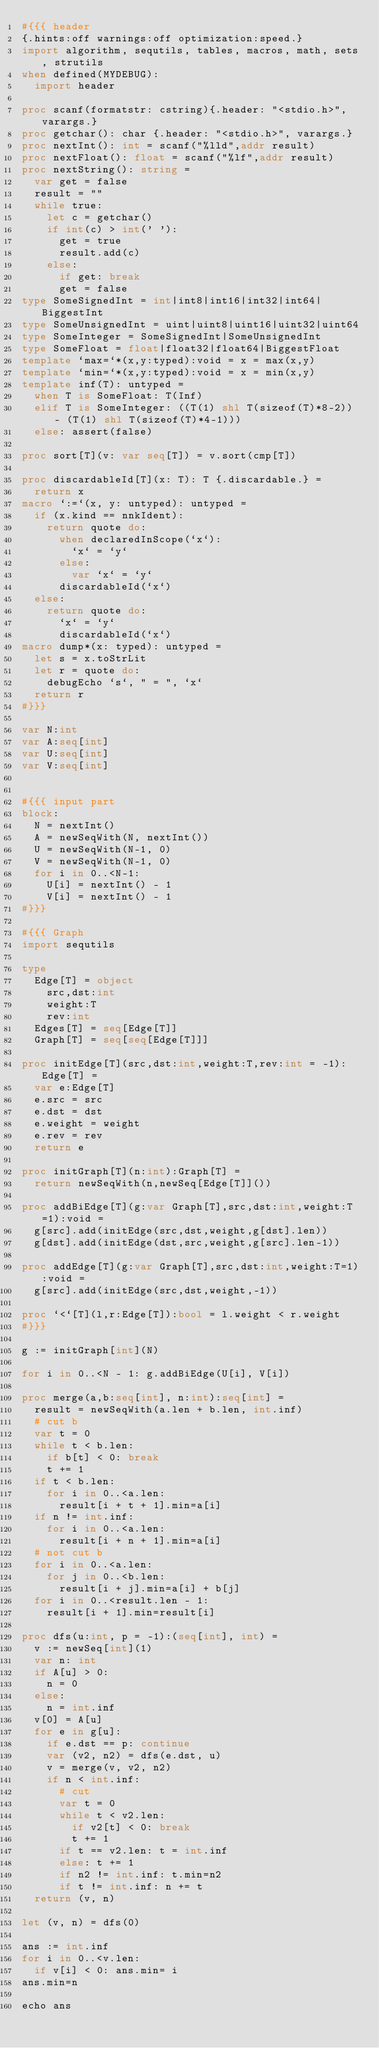Convert code to text. <code><loc_0><loc_0><loc_500><loc_500><_Nim_>#{{{ header
{.hints:off warnings:off optimization:speed.}
import algorithm, sequtils, tables, macros, math, sets, strutils
when defined(MYDEBUG):
  import header

proc scanf(formatstr: cstring){.header: "<stdio.h>", varargs.}
proc getchar(): char {.header: "<stdio.h>", varargs.}
proc nextInt(): int = scanf("%lld",addr result)
proc nextFloat(): float = scanf("%lf",addr result)
proc nextString(): string =
  var get = false
  result = ""
  while true:
    let c = getchar()
    if int(c) > int(' '):
      get = true
      result.add(c)
    else:
      if get: break
      get = false
type SomeSignedInt = int|int8|int16|int32|int64|BiggestInt
type SomeUnsignedInt = uint|uint8|uint16|uint32|uint64
type SomeInteger = SomeSignedInt|SomeUnsignedInt
type SomeFloat = float|float32|float64|BiggestFloat
template `max=`*(x,y:typed):void = x = max(x,y)
template `min=`*(x,y:typed):void = x = min(x,y)
template inf(T): untyped = 
  when T is SomeFloat: T(Inf)
  elif T is SomeInteger: ((T(1) shl T(sizeof(T)*8-2)) - (T(1) shl T(sizeof(T)*4-1)))
  else: assert(false)

proc sort[T](v: var seq[T]) = v.sort(cmp[T])

proc discardableId[T](x: T): T {.discardable.} =
  return x
macro `:=`(x, y: untyped): untyped =
  if (x.kind == nnkIdent):
    return quote do:
      when declaredInScope(`x`):
        `x` = `y`
      else:
        var `x` = `y`
      discardableId(`x`)
  else:
    return quote do:
      `x` = `y`
      discardableId(`x`)
macro dump*(x: typed): untyped =
  let s = x.toStrLit
  let r = quote do:
    debugEcho `s`, " = ", `x`
  return r
#}}}

var N:int
var A:seq[int]
var U:seq[int]
var V:seq[int]


#{{{ input part
block:
  N = nextInt()
  A = newSeqWith(N, nextInt())
  U = newSeqWith(N-1, 0)
  V = newSeqWith(N-1, 0)
  for i in 0..<N-1:
    U[i] = nextInt() - 1
    V[i] = nextInt() - 1
#}}}

#{{{ Graph
import sequtils

type
  Edge[T] = object
    src,dst:int
    weight:T
    rev:int
  Edges[T] = seq[Edge[T]]
  Graph[T] = seq[seq[Edge[T]]]

proc initEdge[T](src,dst:int,weight:T,rev:int = -1):Edge[T] =
  var e:Edge[T]
  e.src = src
  e.dst = dst
  e.weight = weight
  e.rev = rev
  return e

proc initGraph[T](n:int):Graph[T] =
  return newSeqWith(n,newSeq[Edge[T]]())

proc addBiEdge[T](g:var Graph[T],src,dst:int,weight:T=1):void =
  g[src].add(initEdge(src,dst,weight,g[dst].len))
  g[dst].add(initEdge(dst,src,weight,g[src].len-1))

proc addEdge[T](g:var Graph[T],src,dst:int,weight:T=1):void =
  g[src].add(initEdge(src,dst,weight,-1))

proc `<`[T](l,r:Edge[T]):bool = l.weight < r.weight
#}}}

g := initGraph[int](N)

for i in 0..<N - 1: g.addBiEdge(U[i], V[i])

proc merge(a,b:seq[int], n:int):seq[int] =
  result = newSeqWith(a.len + b.len, int.inf)
  # cut b
  var t = 0
  while t < b.len:
    if b[t] < 0: break
    t += 1
  if t < b.len:
    for i in 0..<a.len:
      result[i + t + 1].min=a[i]
  if n != int.inf:
    for i in 0..<a.len:
      result[i + n + 1].min=a[i]
  # not cut b
  for i in 0..<a.len:
    for j in 0..<b.len:
      result[i + j].min=a[i] + b[j]
  for i in 0..<result.len - 1:
    result[i + 1].min=result[i]

proc dfs(u:int, p = -1):(seq[int], int) =
  v := newSeq[int](1)
  var n: int
  if A[u] > 0:
    n = 0
  else:
    n = int.inf
  v[0] = A[u]
  for e in g[u]:
    if e.dst == p: continue
    var (v2, n2) = dfs(e.dst, u)
    v = merge(v, v2, n2)
    if n < int.inf:
      # cut
      var t = 0
      while t < v2.len:
        if v2[t] < 0: break
        t += 1
      if t == v2.len: t = int.inf
      else: t += 1
      if n2 != int.inf: t.min=n2
      if t != int.inf: n += t
  return (v, n)

let (v, n) = dfs(0)

ans := int.inf
for i in 0..<v.len:
  if v[i] < 0: ans.min= i
ans.min=n

echo ans
</code> 